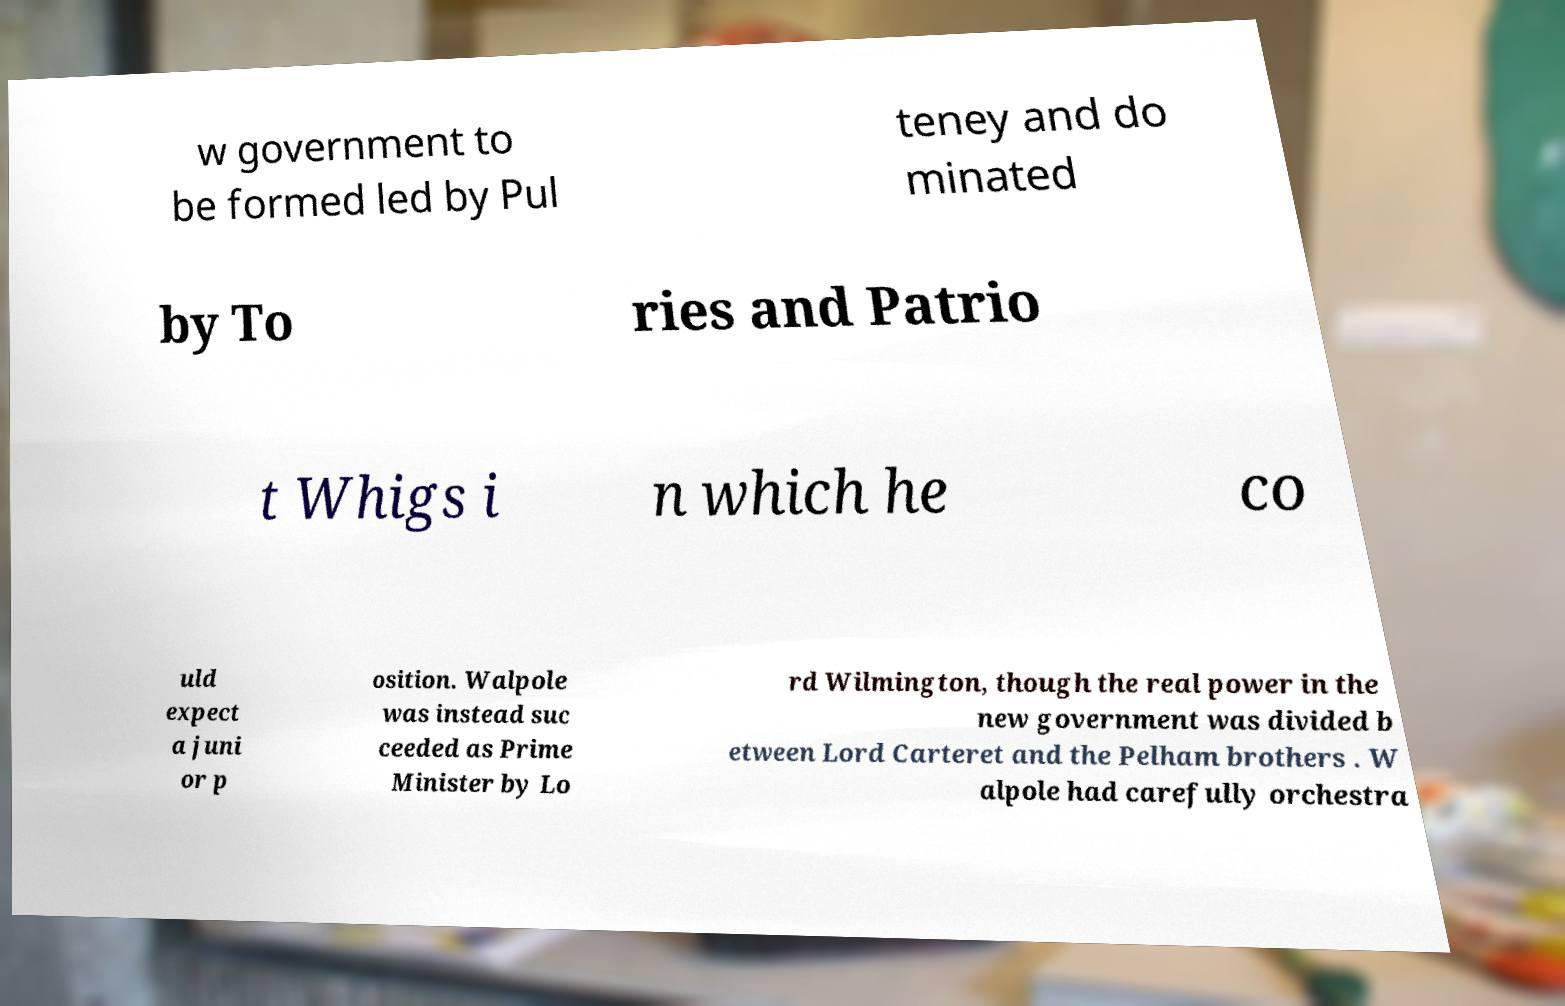Please read and relay the text visible in this image. What does it say? w government to be formed led by Pul teney and do minated by To ries and Patrio t Whigs i n which he co uld expect a juni or p osition. Walpole was instead suc ceeded as Prime Minister by Lo rd Wilmington, though the real power in the new government was divided b etween Lord Carteret and the Pelham brothers . W alpole had carefully orchestra 